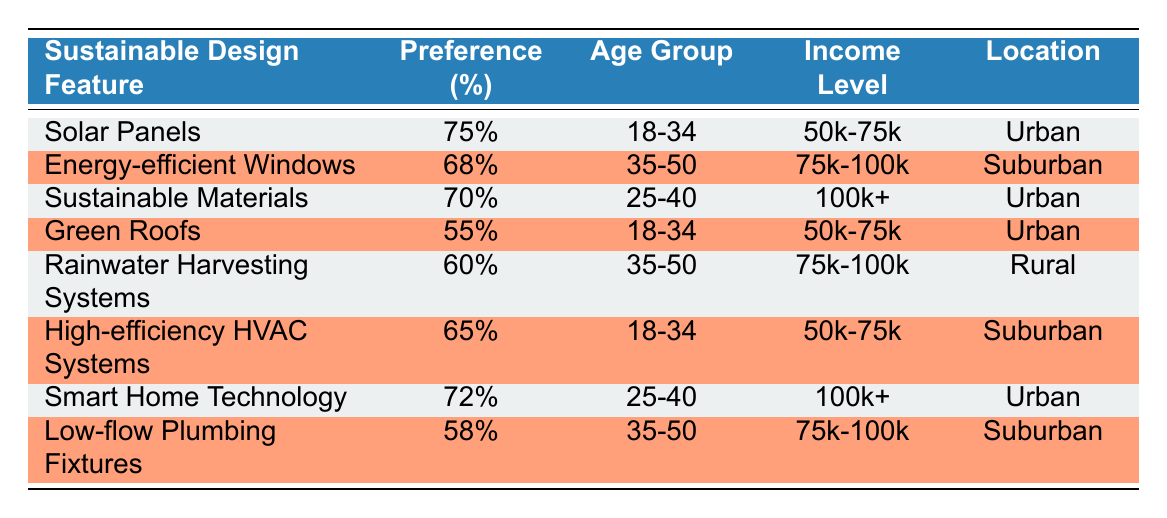What is the percentage preference for Solar Panels? The table shows the percentage preference for Solar Panels as listed in the first row, which states 75% under the Preference column.
Answer: 75% Which sustainable design feature has the lowest percentage preference? By reviewing the percentage preferences from each row, Green Roofs has the lowest percentage preference at 55%.
Answer: Green Roofs How many features have an age group of 18-34 years? The features for the age group 18-34 are Solar Panels, Green Roofs, and High-efficiency HVAC Systems. This totals to 3 features.
Answer: 3 What is the average percentage preference for features located in Urban areas? The Urban features and their preferences are: Solar Panels (75%), Sustainable Materials (70%), Smart Home Technology (72%), and Green Roofs (55%). Calculating the average: (75 + 70 + 72 + 55) / 4 = 67.5%.
Answer: 67.5% Do more respondents in the 35-50 age group prefer Energy-efficient Windows than Low-flow Plumbing Fixtures? The preference for Energy-efficient Windows is 68%, while for Low-flow Plumbing Fixtures it is 58%. Since 68% is greater than 58%, the statement is true.
Answer: Yes What is the total percentage preference of all features listed for age group 25-40? The percentage preferences for age group 25-40 are Sustainable Materials (70%) and Smart Home Technology (72%). Summing these gives: 70 + 72 = 142%.
Answer: 142% Which location has a feature with the highest preference percentage? Comparing all entries, we see Solar Panels in Urban areas has the highest preference at 75%.
Answer: Urban Is there any sustainable design feature with a preference over 65% that is located in a Rural area? Reviewing the table, the only feature in Rural is Rainwater Harvesting Systems, which has a preference of 60%. Since 60% is less than 65%, the answer is no.
Answer: No 